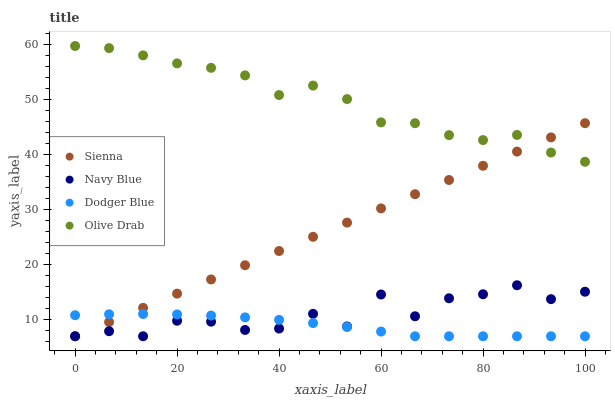Does Dodger Blue have the minimum area under the curve?
Answer yes or no. Yes. Does Olive Drab have the maximum area under the curve?
Answer yes or no. Yes. Does Navy Blue have the minimum area under the curve?
Answer yes or no. No. Does Navy Blue have the maximum area under the curve?
Answer yes or no. No. Is Sienna the smoothest?
Answer yes or no. Yes. Is Navy Blue the roughest?
Answer yes or no. Yes. Is Dodger Blue the smoothest?
Answer yes or no. No. Is Dodger Blue the roughest?
Answer yes or no. No. Does Sienna have the lowest value?
Answer yes or no. Yes. Does Olive Drab have the lowest value?
Answer yes or no. No. Does Olive Drab have the highest value?
Answer yes or no. Yes. Does Navy Blue have the highest value?
Answer yes or no. No. Is Dodger Blue less than Olive Drab?
Answer yes or no. Yes. Is Olive Drab greater than Navy Blue?
Answer yes or no. Yes. Does Sienna intersect Navy Blue?
Answer yes or no. Yes. Is Sienna less than Navy Blue?
Answer yes or no. No. Is Sienna greater than Navy Blue?
Answer yes or no. No. Does Dodger Blue intersect Olive Drab?
Answer yes or no. No. 